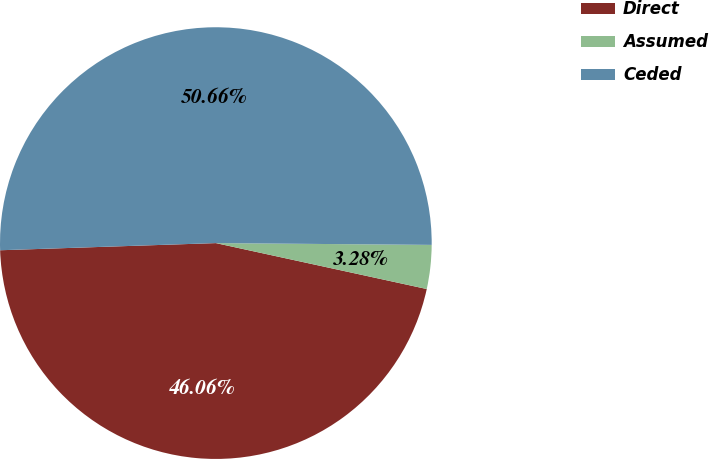Convert chart. <chart><loc_0><loc_0><loc_500><loc_500><pie_chart><fcel>Direct<fcel>Assumed<fcel>Ceded<nl><fcel>46.06%<fcel>3.28%<fcel>50.66%<nl></chart> 